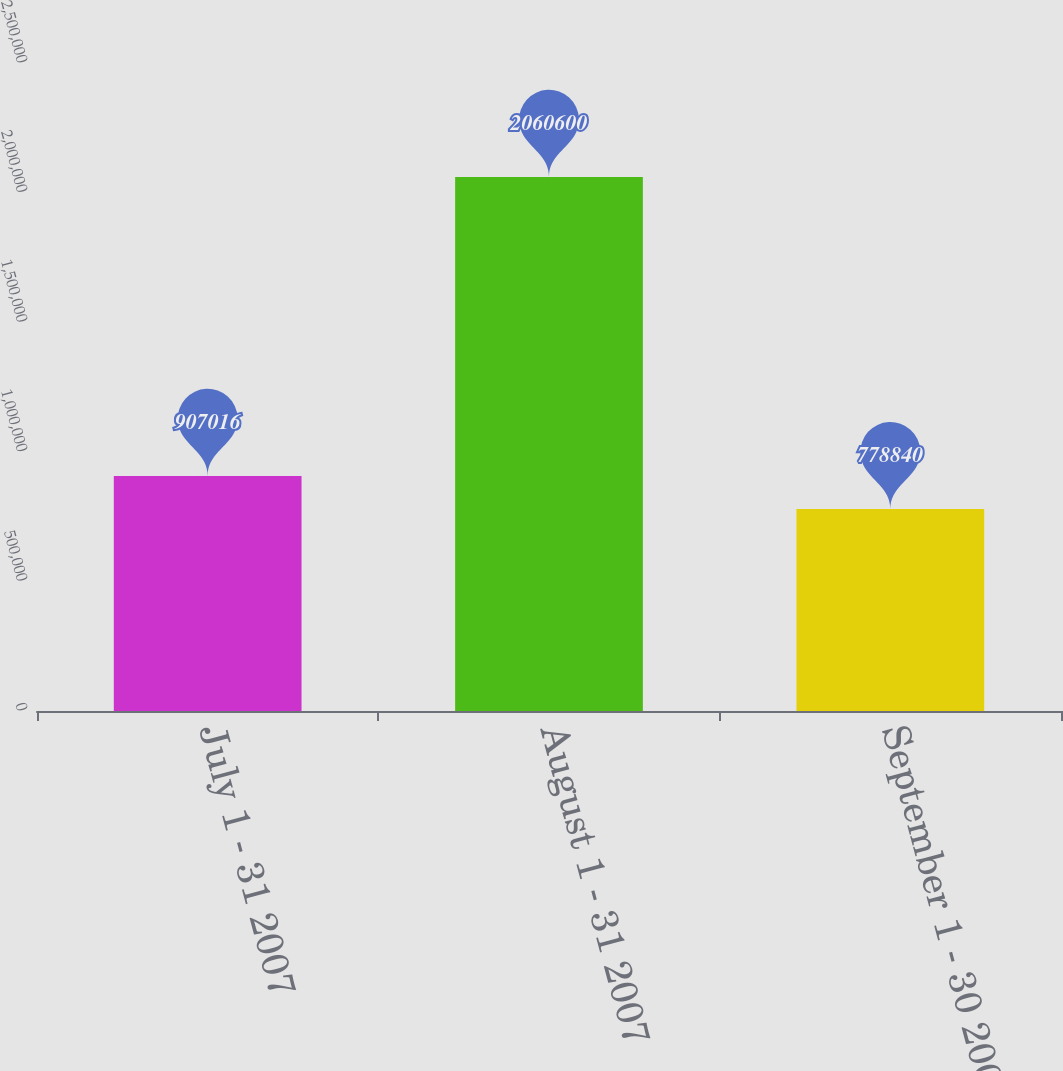<chart> <loc_0><loc_0><loc_500><loc_500><bar_chart><fcel>July 1 - 31 2007<fcel>August 1 - 31 2007<fcel>September 1 - 30 2007<nl><fcel>907016<fcel>2.0606e+06<fcel>778840<nl></chart> 